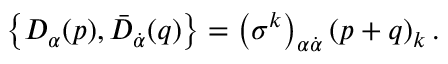Convert formula to latex. <formula><loc_0><loc_0><loc_500><loc_500>\left \{ D _ { \alpha } ( p ) , \bar { D } _ { \dot { \alpha } } ( q ) \right \} = \left ( \sigma ^ { k } \right ) _ { \alpha \dot { \alpha } } \left ( p + q \right ) _ { k } .</formula> 